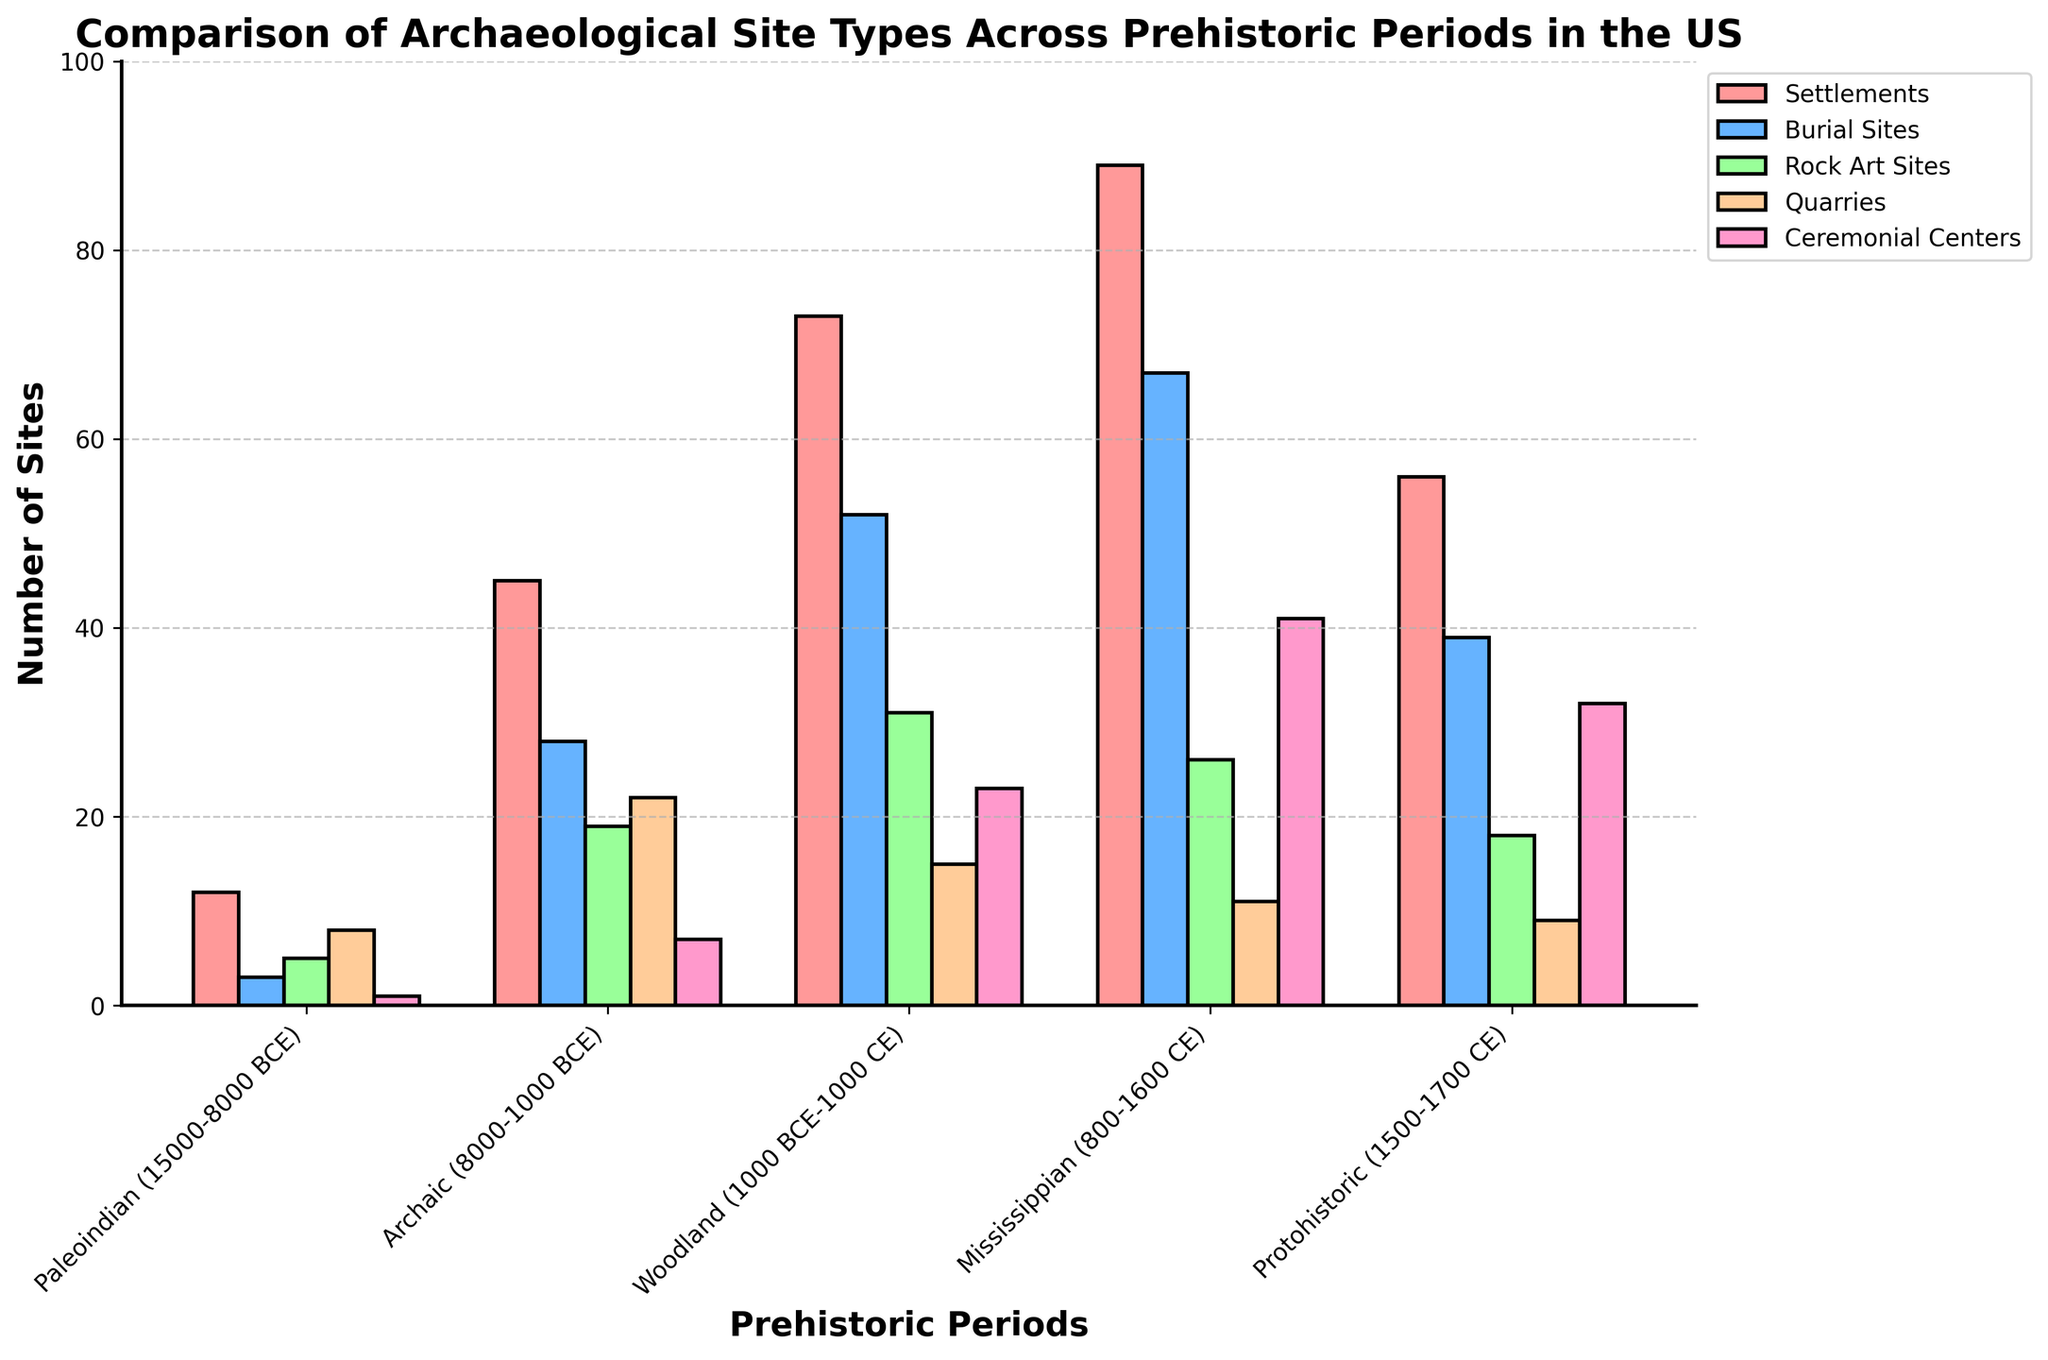What's the period with the highest number of ceremonial centers? To determine the period with the highest number of ceremonial centers, we examine the "Ceremonial Centers" values across all periods: Paleoindian (1), Archaic (7), Woodland (23), Mississippian (41), and Protohistoric (32). The Mississippian period has the highest value at 41.
Answer: Mississippian Which period has the fewest burial sites, and how many are there? To find the period with the fewest burial sites, we examine the "Burial Sites" values: Paleoindian (3), Archaic (28), Woodland (52), Mississippian (67), and Protohistoric (39). The Paleoindian period has the fewest burial sites at 3.
Answer: Paleoindian, 3 Compare the number of rock art sites in the Archaic and Protohistoric periods. Which period has more? We compare the "Rock Art Sites" values for the Archaic (19) and Protohistoric (18) periods. The Archaic period has one more rock art site than the Protohistoric.
Answer: Archaic What is the total number of sites in the Woodland period across all site types? To find the total number of sites in the Woodland period, we sum the values: Settlements (73), Burial Sites (52), Rock Art Sites (31), Quarries (15), and Ceremonial Centers (23). Total = 73 + 52 + 31 + 15 + 23 = 194.
Answer: 194 What period had the largest increase in the number of settlements compared to its preceding period? To determine which period had the largest increase in settlements compared to the preceding period, we calculate the differences: Archaic-Paleoindian (45-12=33), Woodland-Archaic (73-45=28), Mississippian-Woodland (89-73=16), and Protohistoric-Mississippian (56-89=-33). The largest increase is from Paleoindian to Archaic with an increase of 33.
Answer: Archaic Visually, which site type is represented by the green bars, and in which period does it reach its maximum value? The green bars represent "Rock Art Sites." To determine the period with the maximum value, we look at the heights of the green bars: Paleoindian (5), Archaic (19), Woodland (31), Mississippian (26), Protohistoric (18). The maximum value of 31 is reached during the Woodland period.
Answer: Rock Art Sites, Woodland What is the average number of quarries across all periods? To find the average number of quarries, we sum the "Quarries" values and divide by the number of periods: (8 + 22 + 15 + 11 + 9) / 5 = 65 / 5 = 13.
Answer: 13 Between the Mississippian and Protohistoric periods, which has a higher number of ceremonial centers, and by how much? We compare "Ceremonial Centers" values for Mississippian (41) and Protohistoric (32). The Mississippian period has 41 - 32 = 9 more ceremonial centers than the Protohistoric.
Answer: Mississippian, 9 